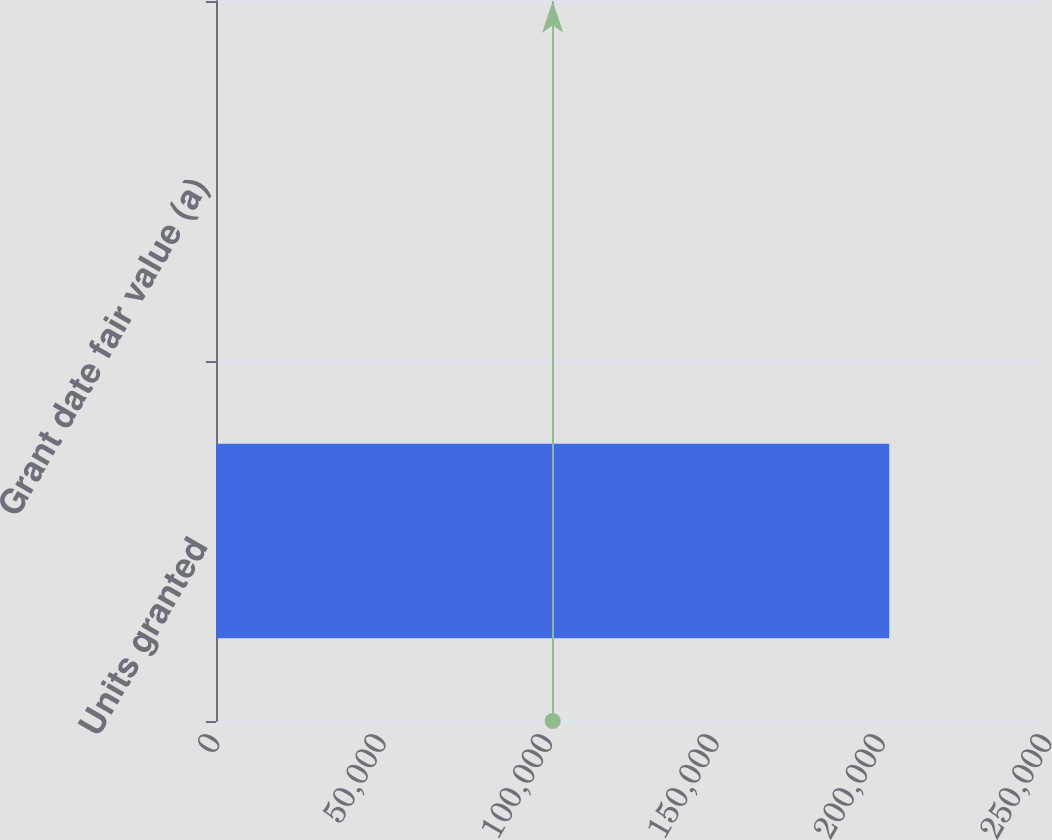<chart> <loc_0><loc_0><loc_500><loc_500><bar_chart><fcel>Units granted<fcel>Grant date fair value (a)<nl><fcel>202278<fcel>49.31<nl></chart> 